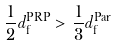<formula> <loc_0><loc_0><loc_500><loc_500>\frac { 1 } { 2 } d ^ { \text {PRP} } _ { \text {f} } > \frac { 1 } { 3 } d ^ { \text {Par} } _ { \text {f} }</formula> 